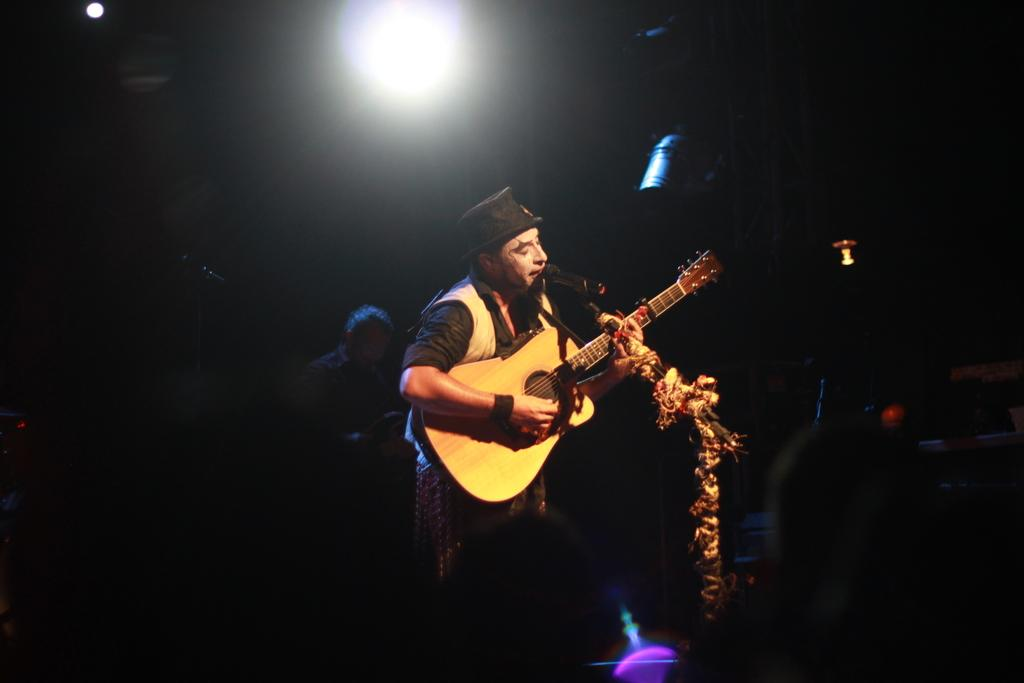What is the man in the image doing? The man is playing a guitar, singing, and using a microphone. What is the man wearing on his head? The man is wearing a cap. Can you describe the person behind the man? There is a person visible behind the man, but no specific details are provided. What is the source of light on the roof? There is a light on the roof. What is the name of the kettle in the image? There is no kettle present in the image. What type of skirt is the man wearing in the image? The man is not wearing a skirt in the image; he is wearing a cap. 